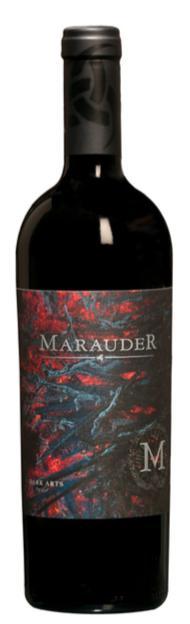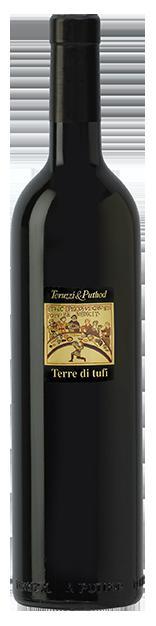The first image is the image on the left, the second image is the image on the right. For the images displayed, is the sentence "The combined images include at least two wine bottles with white-background labels." factually correct? Answer yes or no. No. The first image is the image on the left, the second image is the image on the right. Analyze the images presented: Is the assertion "The label of the bottle of red wine has the words Three Thieves in gold writing." valid? Answer yes or no. No. 